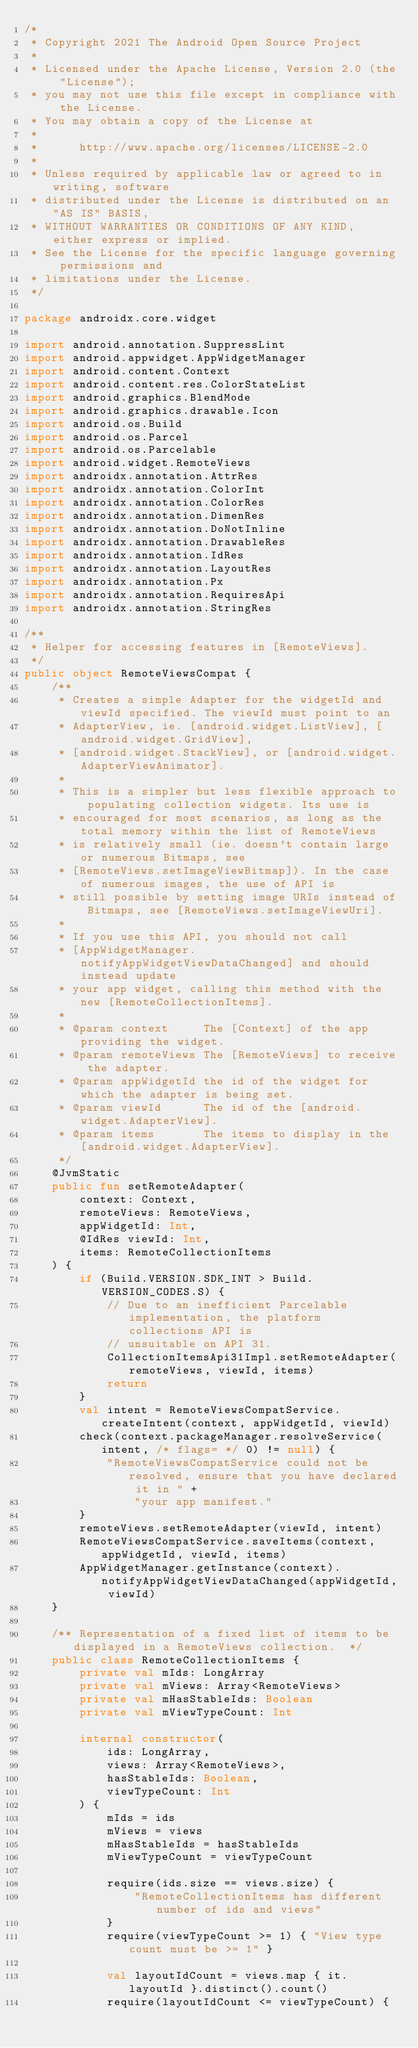Convert code to text. <code><loc_0><loc_0><loc_500><loc_500><_Kotlin_>/*
 * Copyright 2021 The Android Open Source Project
 *
 * Licensed under the Apache License, Version 2.0 (the "License");
 * you may not use this file except in compliance with the License.
 * You may obtain a copy of the License at
 *
 *      http://www.apache.org/licenses/LICENSE-2.0
 *
 * Unless required by applicable law or agreed to in writing, software
 * distributed under the License is distributed on an "AS IS" BASIS,
 * WITHOUT WARRANTIES OR CONDITIONS OF ANY KIND, either express or implied.
 * See the License for the specific language governing permissions and
 * limitations under the License.
 */

package androidx.core.widget

import android.annotation.SuppressLint
import android.appwidget.AppWidgetManager
import android.content.Context
import android.content.res.ColorStateList
import android.graphics.BlendMode
import android.graphics.drawable.Icon
import android.os.Build
import android.os.Parcel
import android.os.Parcelable
import android.widget.RemoteViews
import androidx.annotation.AttrRes
import androidx.annotation.ColorInt
import androidx.annotation.ColorRes
import androidx.annotation.DimenRes
import androidx.annotation.DoNotInline
import androidx.annotation.DrawableRes
import androidx.annotation.IdRes
import androidx.annotation.LayoutRes
import androidx.annotation.Px
import androidx.annotation.RequiresApi
import androidx.annotation.StringRes

/**
 * Helper for accessing features in [RemoteViews].
 */
public object RemoteViewsCompat {
    /**
     * Creates a simple Adapter for the widgetId and viewId specified. The viewId must point to an
     * AdapterView, ie. [android.widget.ListView], [android.widget.GridView],
     * [android.widget.StackView], or [android.widget.AdapterViewAnimator].
     *
     * This is a simpler but less flexible approach to populating collection widgets. Its use is
     * encouraged for most scenarios, as long as the total memory within the list of RemoteViews
     * is relatively small (ie. doesn't contain large or numerous Bitmaps, see
     * [RemoteViews.setImageViewBitmap]). In the case of numerous images, the use of API is
     * still possible by setting image URIs instead of Bitmaps, see [RemoteViews.setImageViewUri].
     *
     * If you use this API, you should not call
     * [AppWidgetManager.notifyAppWidgetViewDataChanged] and should instead update
     * your app widget, calling this method with the new [RemoteCollectionItems].
     *
     * @param context     The [Context] of the app providing the widget.
     * @param remoteViews The [RemoteViews] to receive the adapter.
     * @param appWidgetId the id of the widget for which the adapter is being set.
     * @param viewId      The id of the [android.widget.AdapterView].
     * @param items       The items to display in the [android.widget.AdapterView].
     */
    @JvmStatic
    public fun setRemoteAdapter(
        context: Context,
        remoteViews: RemoteViews,
        appWidgetId: Int,
        @IdRes viewId: Int,
        items: RemoteCollectionItems
    ) {
        if (Build.VERSION.SDK_INT > Build.VERSION_CODES.S) {
            // Due to an inefficient Parcelable implementation, the platform collections API is
            // unsuitable on API 31.
            CollectionItemsApi31Impl.setRemoteAdapter(remoteViews, viewId, items)
            return
        }
        val intent = RemoteViewsCompatService.createIntent(context, appWidgetId, viewId)
        check(context.packageManager.resolveService(intent, /* flags= */ 0) != null) {
            "RemoteViewsCompatService could not be resolved, ensure that you have declared it in " +
                "your app manifest."
        }
        remoteViews.setRemoteAdapter(viewId, intent)
        RemoteViewsCompatService.saveItems(context, appWidgetId, viewId, items)
        AppWidgetManager.getInstance(context).notifyAppWidgetViewDataChanged(appWidgetId, viewId)
    }

    /** Representation of a fixed list of items to be displayed in a RemoteViews collection.  */
    public class RemoteCollectionItems {
        private val mIds: LongArray
        private val mViews: Array<RemoteViews>
        private val mHasStableIds: Boolean
        private val mViewTypeCount: Int

        internal constructor(
            ids: LongArray,
            views: Array<RemoteViews>,
            hasStableIds: Boolean,
            viewTypeCount: Int
        ) {
            mIds = ids
            mViews = views
            mHasStableIds = hasStableIds
            mViewTypeCount = viewTypeCount

            require(ids.size == views.size) {
                "RemoteCollectionItems has different number of ids and views"
            }
            require(viewTypeCount >= 1) { "View type count must be >= 1" }

            val layoutIdCount = views.map { it.layoutId }.distinct().count()
            require(layoutIdCount <= viewTypeCount) {</code> 